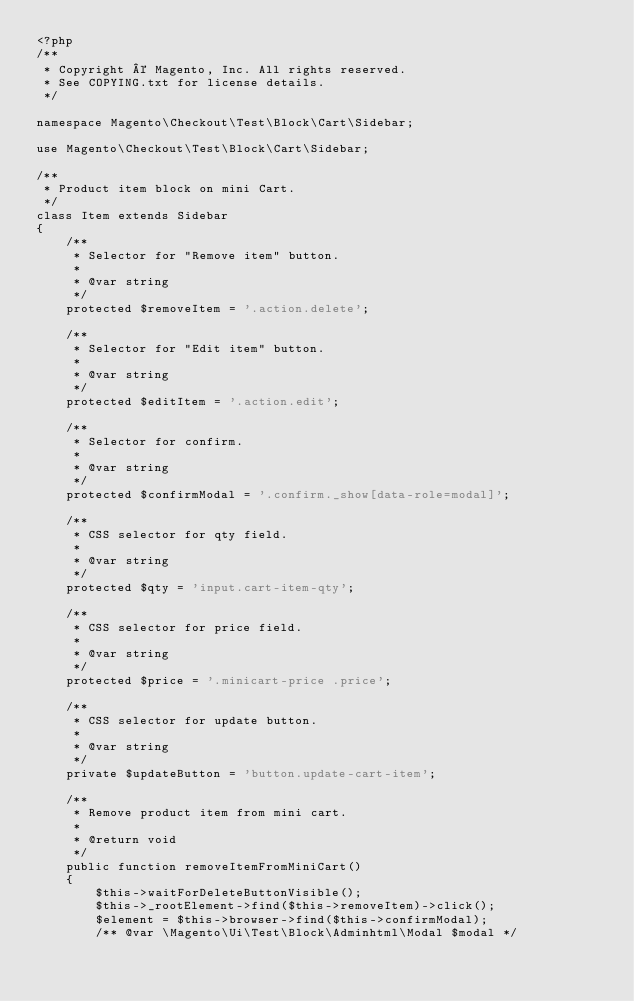Convert code to text. <code><loc_0><loc_0><loc_500><loc_500><_PHP_><?php
/**
 * Copyright © Magento, Inc. All rights reserved.
 * See COPYING.txt for license details.
 */

namespace Magento\Checkout\Test\Block\Cart\Sidebar;

use Magento\Checkout\Test\Block\Cart\Sidebar;

/**
 * Product item block on mini Cart.
 */
class Item extends Sidebar
{
    /**
     * Selector for "Remove item" button.
     *
     * @var string
     */
    protected $removeItem = '.action.delete';

    /**
     * Selector for "Edit item" button.
     *
     * @var string
     */
    protected $editItem = '.action.edit';

    /**
     * Selector for confirm.
     *
     * @var string
     */
    protected $confirmModal = '.confirm._show[data-role=modal]';

    /**
     * CSS selector for qty field.
     *
     * @var string
     */
    protected $qty = 'input.cart-item-qty';

    /**
     * CSS selector for price field.
     *
     * @var string
     */
    protected $price = '.minicart-price .price';

    /**
     * CSS selector for update button.
     *
     * @var string
     */
    private $updateButton = 'button.update-cart-item';

    /**
     * Remove product item from mini cart.
     *
     * @return void
     */
    public function removeItemFromMiniCart()
    {
        $this->waitForDeleteButtonVisible();
        $this->_rootElement->find($this->removeItem)->click();
        $element = $this->browser->find($this->confirmModal);
        /** @var \Magento\Ui\Test\Block\Adminhtml\Modal $modal */</code> 